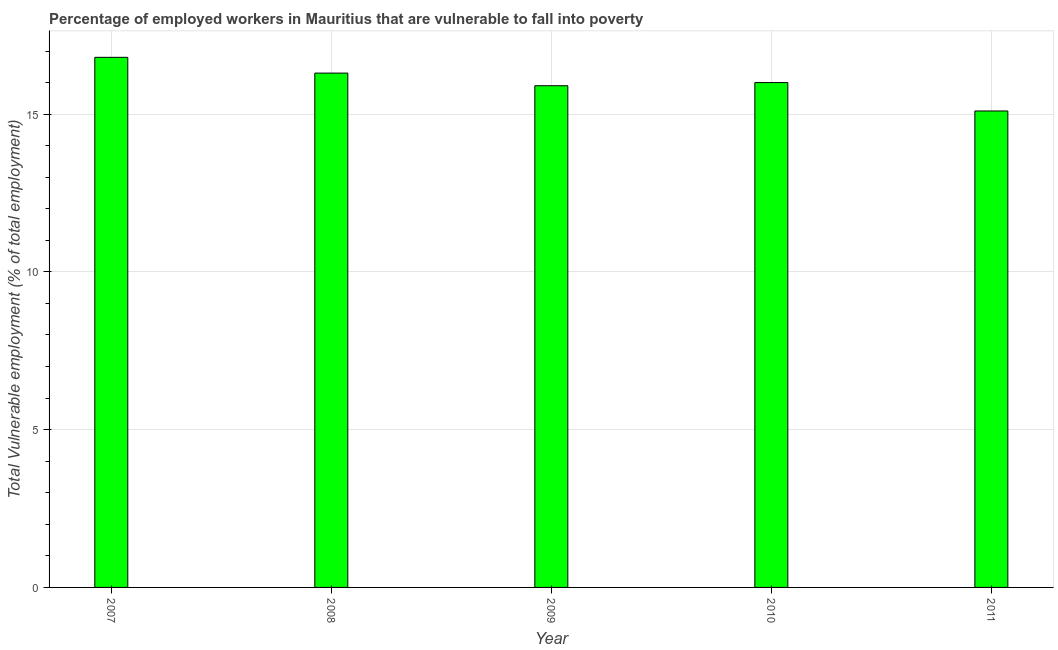Does the graph contain any zero values?
Offer a very short reply. No. Does the graph contain grids?
Offer a terse response. Yes. What is the title of the graph?
Ensure brevity in your answer.  Percentage of employed workers in Mauritius that are vulnerable to fall into poverty. What is the label or title of the X-axis?
Provide a short and direct response. Year. What is the label or title of the Y-axis?
Provide a succinct answer. Total Vulnerable employment (% of total employment). What is the total vulnerable employment in 2008?
Provide a short and direct response. 16.3. Across all years, what is the maximum total vulnerable employment?
Give a very brief answer. 16.8. Across all years, what is the minimum total vulnerable employment?
Give a very brief answer. 15.1. In which year was the total vulnerable employment maximum?
Keep it short and to the point. 2007. In which year was the total vulnerable employment minimum?
Provide a succinct answer. 2011. What is the sum of the total vulnerable employment?
Offer a very short reply. 80.1. What is the difference between the total vulnerable employment in 2008 and 2011?
Provide a short and direct response. 1.2. What is the average total vulnerable employment per year?
Provide a short and direct response. 16.02. What is the median total vulnerable employment?
Ensure brevity in your answer.  16. What is the ratio of the total vulnerable employment in 2007 to that in 2011?
Your response must be concise. 1.11. What is the difference between the highest and the second highest total vulnerable employment?
Offer a terse response. 0.5. What is the difference between the highest and the lowest total vulnerable employment?
Your answer should be very brief. 1.7. In how many years, is the total vulnerable employment greater than the average total vulnerable employment taken over all years?
Your answer should be very brief. 2. How many bars are there?
Your answer should be very brief. 5. Are all the bars in the graph horizontal?
Ensure brevity in your answer.  No. How many years are there in the graph?
Provide a succinct answer. 5. What is the Total Vulnerable employment (% of total employment) of 2007?
Provide a short and direct response. 16.8. What is the Total Vulnerable employment (% of total employment) in 2008?
Your answer should be compact. 16.3. What is the Total Vulnerable employment (% of total employment) in 2009?
Offer a terse response. 15.9. What is the Total Vulnerable employment (% of total employment) of 2011?
Offer a terse response. 15.1. What is the difference between the Total Vulnerable employment (% of total employment) in 2007 and 2009?
Ensure brevity in your answer.  0.9. What is the difference between the Total Vulnerable employment (% of total employment) in 2007 and 2010?
Offer a terse response. 0.8. What is the difference between the Total Vulnerable employment (% of total employment) in 2007 and 2011?
Your answer should be compact. 1.7. What is the difference between the Total Vulnerable employment (% of total employment) in 2008 and 2010?
Ensure brevity in your answer.  0.3. What is the difference between the Total Vulnerable employment (% of total employment) in 2008 and 2011?
Provide a short and direct response. 1.2. What is the difference between the Total Vulnerable employment (% of total employment) in 2009 and 2010?
Ensure brevity in your answer.  -0.1. What is the difference between the Total Vulnerable employment (% of total employment) in 2010 and 2011?
Offer a very short reply. 0.9. What is the ratio of the Total Vulnerable employment (% of total employment) in 2007 to that in 2008?
Your answer should be compact. 1.03. What is the ratio of the Total Vulnerable employment (% of total employment) in 2007 to that in 2009?
Offer a very short reply. 1.06. What is the ratio of the Total Vulnerable employment (% of total employment) in 2007 to that in 2010?
Provide a short and direct response. 1.05. What is the ratio of the Total Vulnerable employment (% of total employment) in 2007 to that in 2011?
Your answer should be very brief. 1.11. What is the ratio of the Total Vulnerable employment (% of total employment) in 2008 to that in 2010?
Ensure brevity in your answer.  1.02. What is the ratio of the Total Vulnerable employment (% of total employment) in 2008 to that in 2011?
Provide a short and direct response. 1.08. What is the ratio of the Total Vulnerable employment (% of total employment) in 2009 to that in 2010?
Provide a short and direct response. 0.99. What is the ratio of the Total Vulnerable employment (% of total employment) in 2009 to that in 2011?
Keep it short and to the point. 1.05. What is the ratio of the Total Vulnerable employment (% of total employment) in 2010 to that in 2011?
Your response must be concise. 1.06. 